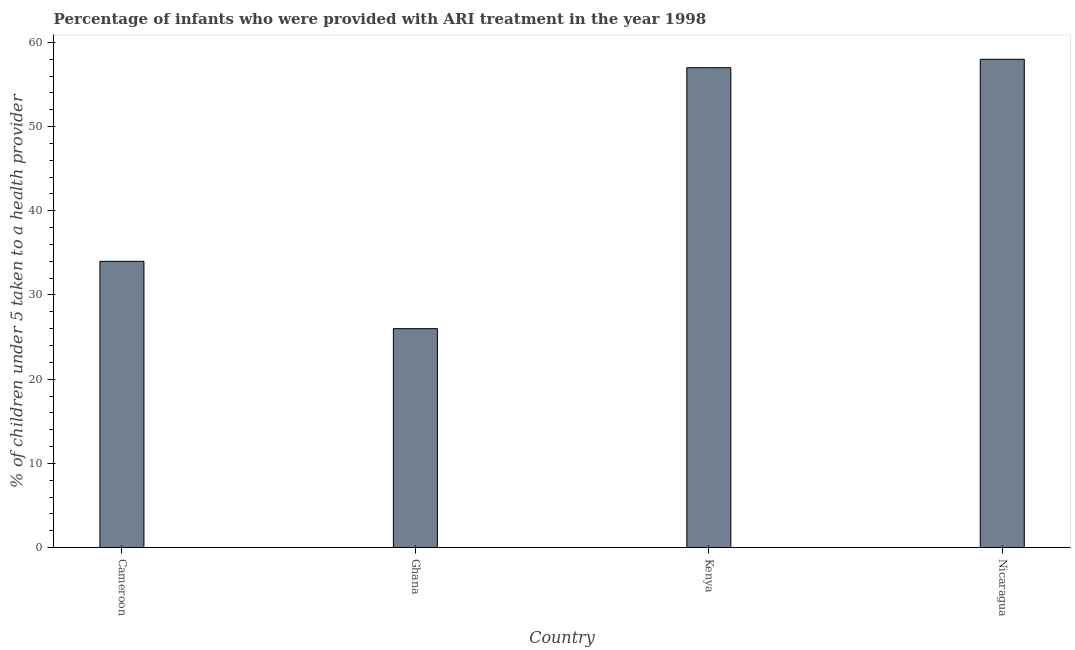What is the title of the graph?
Give a very brief answer. Percentage of infants who were provided with ARI treatment in the year 1998. What is the label or title of the Y-axis?
Offer a very short reply. % of children under 5 taken to a health provider. Across all countries, what is the minimum percentage of children who were provided with ari treatment?
Ensure brevity in your answer.  26. In which country was the percentage of children who were provided with ari treatment maximum?
Give a very brief answer. Nicaragua. In which country was the percentage of children who were provided with ari treatment minimum?
Ensure brevity in your answer.  Ghana. What is the sum of the percentage of children who were provided with ari treatment?
Offer a very short reply. 175. What is the difference between the percentage of children who were provided with ari treatment in Ghana and Kenya?
Offer a terse response. -31. What is the median percentage of children who were provided with ari treatment?
Offer a very short reply. 45.5. What is the ratio of the percentage of children who were provided with ari treatment in Cameroon to that in Ghana?
Ensure brevity in your answer.  1.31. Is the percentage of children who were provided with ari treatment in Ghana less than that in Nicaragua?
Make the answer very short. Yes. Is the difference between the percentage of children who were provided with ari treatment in Cameroon and Ghana greater than the difference between any two countries?
Your answer should be compact. No. Is the sum of the percentage of children who were provided with ari treatment in Ghana and Nicaragua greater than the maximum percentage of children who were provided with ari treatment across all countries?
Your response must be concise. Yes. What is the difference between the highest and the lowest percentage of children who were provided with ari treatment?
Provide a succinct answer. 32. How many bars are there?
Your answer should be compact. 4. Are all the bars in the graph horizontal?
Your answer should be very brief. No. How many countries are there in the graph?
Provide a short and direct response. 4. Are the values on the major ticks of Y-axis written in scientific E-notation?
Offer a very short reply. No. What is the % of children under 5 taken to a health provider of Cameroon?
Give a very brief answer. 34. What is the % of children under 5 taken to a health provider in Ghana?
Provide a short and direct response. 26. What is the difference between the % of children under 5 taken to a health provider in Cameroon and Ghana?
Make the answer very short. 8. What is the difference between the % of children under 5 taken to a health provider in Cameroon and Kenya?
Give a very brief answer. -23. What is the difference between the % of children under 5 taken to a health provider in Ghana and Kenya?
Offer a terse response. -31. What is the difference between the % of children under 5 taken to a health provider in Ghana and Nicaragua?
Your answer should be very brief. -32. What is the difference between the % of children under 5 taken to a health provider in Kenya and Nicaragua?
Your answer should be very brief. -1. What is the ratio of the % of children under 5 taken to a health provider in Cameroon to that in Ghana?
Make the answer very short. 1.31. What is the ratio of the % of children under 5 taken to a health provider in Cameroon to that in Kenya?
Your answer should be compact. 0.6. What is the ratio of the % of children under 5 taken to a health provider in Cameroon to that in Nicaragua?
Your answer should be very brief. 0.59. What is the ratio of the % of children under 5 taken to a health provider in Ghana to that in Kenya?
Make the answer very short. 0.46. What is the ratio of the % of children under 5 taken to a health provider in Ghana to that in Nicaragua?
Keep it short and to the point. 0.45. 